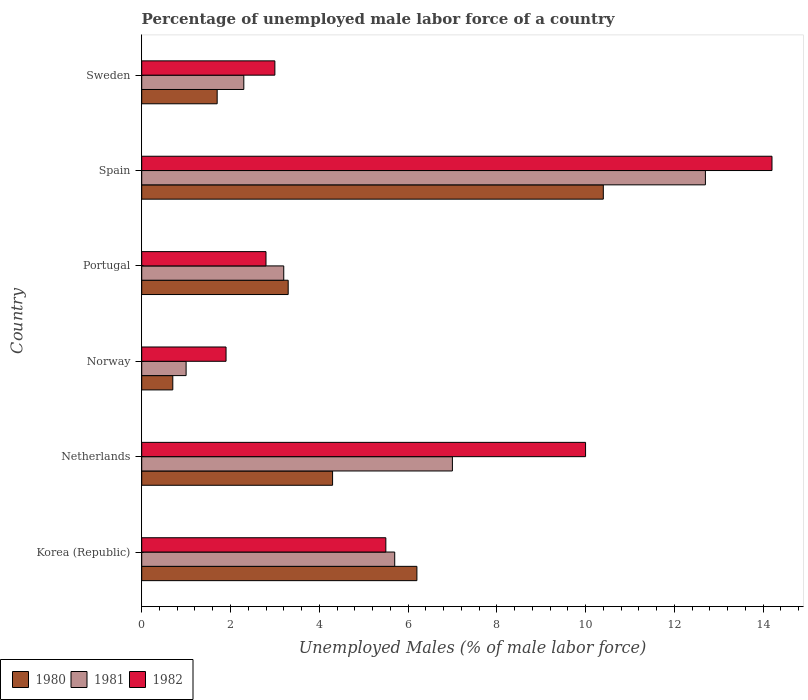Are the number of bars on each tick of the Y-axis equal?
Provide a short and direct response. Yes. How many bars are there on the 3rd tick from the top?
Your answer should be very brief. 3. What is the label of the 1st group of bars from the top?
Ensure brevity in your answer.  Sweden. In how many cases, is the number of bars for a given country not equal to the number of legend labels?
Keep it short and to the point. 0. What is the percentage of unemployed male labor force in 1982 in Norway?
Keep it short and to the point. 1.9. Across all countries, what is the maximum percentage of unemployed male labor force in 1981?
Make the answer very short. 12.7. Across all countries, what is the minimum percentage of unemployed male labor force in 1981?
Offer a terse response. 1. In which country was the percentage of unemployed male labor force in 1980 minimum?
Your answer should be compact. Norway. What is the total percentage of unemployed male labor force in 1980 in the graph?
Provide a succinct answer. 26.6. What is the difference between the percentage of unemployed male labor force in 1981 in Norway and that in Sweden?
Keep it short and to the point. -1.3. What is the difference between the percentage of unemployed male labor force in 1982 in Netherlands and the percentage of unemployed male labor force in 1981 in Portugal?
Your response must be concise. 6.8. What is the average percentage of unemployed male labor force in 1981 per country?
Provide a succinct answer. 5.32. What is the difference between the percentage of unemployed male labor force in 1980 and percentage of unemployed male labor force in 1981 in Norway?
Offer a very short reply. -0.3. In how many countries, is the percentage of unemployed male labor force in 1980 greater than 4.8 %?
Offer a terse response. 2. What is the ratio of the percentage of unemployed male labor force in 1980 in Norway to that in Sweden?
Your answer should be compact. 0.41. Is the percentage of unemployed male labor force in 1982 in Korea (Republic) less than that in Spain?
Make the answer very short. Yes. What is the difference between the highest and the second highest percentage of unemployed male labor force in 1981?
Provide a succinct answer. 5.7. What is the difference between the highest and the lowest percentage of unemployed male labor force in 1980?
Provide a short and direct response. 9.7. What does the 3rd bar from the top in Netherlands represents?
Provide a short and direct response. 1980. What does the 1st bar from the bottom in Portugal represents?
Ensure brevity in your answer.  1980. How many bars are there?
Your answer should be compact. 18. Are all the bars in the graph horizontal?
Your answer should be compact. Yes. How many countries are there in the graph?
Make the answer very short. 6. Does the graph contain any zero values?
Provide a succinct answer. No. Does the graph contain grids?
Your answer should be compact. No. How many legend labels are there?
Ensure brevity in your answer.  3. How are the legend labels stacked?
Offer a very short reply. Horizontal. What is the title of the graph?
Make the answer very short. Percentage of unemployed male labor force of a country. What is the label or title of the X-axis?
Give a very brief answer. Unemployed Males (% of male labor force). What is the label or title of the Y-axis?
Your response must be concise. Country. What is the Unemployed Males (% of male labor force) in 1980 in Korea (Republic)?
Your answer should be compact. 6.2. What is the Unemployed Males (% of male labor force) of 1981 in Korea (Republic)?
Provide a succinct answer. 5.7. What is the Unemployed Males (% of male labor force) in 1982 in Korea (Republic)?
Offer a terse response. 5.5. What is the Unemployed Males (% of male labor force) of 1980 in Netherlands?
Give a very brief answer. 4.3. What is the Unemployed Males (% of male labor force) of 1982 in Netherlands?
Provide a succinct answer. 10. What is the Unemployed Males (% of male labor force) in 1980 in Norway?
Offer a terse response. 0.7. What is the Unemployed Males (% of male labor force) of 1981 in Norway?
Make the answer very short. 1. What is the Unemployed Males (% of male labor force) of 1982 in Norway?
Ensure brevity in your answer.  1.9. What is the Unemployed Males (% of male labor force) in 1980 in Portugal?
Keep it short and to the point. 3.3. What is the Unemployed Males (% of male labor force) of 1981 in Portugal?
Ensure brevity in your answer.  3.2. What is the Unemployed Males (% of male labor force) in 1982 in Portugal?
Offer a terse response. 2.8. What is the Unemployed Males (% of male labor force) in 1980 in Spain?
Ensure brevity in your answer.  10.4. What is the Unemployed Males (% of male labor force) of 1981 in Spain?
Make the answer very short. 12.7. What is the Unemployed Males (% of male labor force) in 1982 in Spain?
Offer a terse response. 14.2. What is the Unemployed Males (% of male labor force) in 1980 in Sweden?
Keep it short and to the point. 1.7. What is the Unemployed Males (% of male labor force) of 1981 in Sweden?
Keep it short and to the point. 2.3. What is the Unemployed Males (% of male labor force) in 1982 in Sweden?
Your answer should be very brief. 3. Across all countries, what is the maximum Unemployed Males (% of male labor force) of 1980?
Offer a terse response. 10.4. Across all countries, what is the maximum Unemployed Males (% of male labor force) of 1981?
Keep it short and to the point. 12.7. Across all countries, what is the maximum Unemployed Males (% of male labor force) in 1982?
Keep it short and to the point. 14.2. Across all countries, what is the minimum Unemployed Males (% of male labor force) of 1980?
Offer a terse response. 0.7. Across all countries, what is the minimum Unemployed Males (% of male labor force) in 1982?
Your response must be concise. 1.9. What is the total Unemployed Males (% of male labor force) in 1980 in the graph?
Your answer should be very brief. 26.6. What is the total Unemployed Males (% of male labor force) in 1981 in the graph?
Your answer should be compact. 31.9. What is the total Unemployed Males (% of male labor force) in 1982 in the graph?
Make the answer very short. 37.4. What is the difference between the Unemployed Males (% of male labor force) in 1980 in Korea (Republic) and that in Netherlands?
Make the answer very short. 1.9. What is the difference between the Unemployed Males (% of male labor force) of 1982 in Korea (Republic) and that in Netherlands?
Ensure brevity in your answer.  -4.5. What is the difference between the Unemployed Males (% of male labor force) in 1980 in Korea (Republic) and that in Norway?
Provide a succinct answer. 5.5. What is the difference between the Unemployed Males (% of male labor force) of 1981 in Korea (Republic) and that in Norway?
Your answer should be very brief. 4.7. What is the difference between the Unemployed Males (% of male labor force) of 1980 in Korea (Republic) and that in Portugal?
Provide a succinct answer. 2.9. What is the difference between the Unemployed Males (% of male labor force) in 1982 in Korea (Republic) and that in Portugal?
Your answer should be very brief. 2.7. What is the difference between the Unemployed Males (% of male labor force) in 1980 in Korea (Republic) and that in Spain?
Give a very brief answer. -4.2. What is the difference between the Unemployed Males (% of male labor force) of 1981 in Korea (Republic) and that in Spain?
Your response must be concise. -7. What is the difference between the Unemployed Males (% of male labor force) in 1982 in Korea (Republic) and that in Spain?
Your answer should be compact. -8.7. What is the difference between the Unemployed Males (% of male labor force) in 1980 in Korea (Republic) and that in Sweden?
Your response must be concise. 4.5. What is the difference between the Unemployed Males (% of male labor force) in 1981 in Korea (Republic) and that in Sweden?
Offer a terse response. 3.4. What is the difference between the Unemployed Males (% of male labor force) in 1982 in Korea (Republic) and that in Sweden?
Offer a very short reply. 2.5. What is the difference between the Unemployed Males (% of male labor force) in 1980 in Netherlands and that in Norway?
Provide a short and direct response. 3.6. What is the difference between the Unemployed Males (% of male labor force) in 1980 in Netherlands and that in Portugal?
Your response must be concise. 1. What is the difference between the Unemployed Males (% of male labor force) of 1981 in Netherlands and that in Portugal?
Offer a terse response. 3.8. What is the difference between the Unemployed Males (% of male labor force) in 1982 in Netherlands and that in Portugal?
Provide a short and direct response. 7.2. What is the difference between the Unemployed Males (% of male labor force) in 1981 in Netherlands and that in Spain?
Offer a very short reply. -5.7. What is the difference between the Unemployed Males (% of male labor force) in 1982 in Netherlands and that in Spain?
Keep it short and to the point. -4.2. What is the difference between the Unemployed Males (% of male labor force) of 1980 in Netherlands and that in Sweden?
Keep it short and to the point. 2.6. What is the difference between the Unemployed Males (% of male labor force) in 1980 in Norway and that in Portugal?
Provide a short and direct response. -2.6. What is the difference between the Unemployed Males (% of male labor force) of 1980 in Norway and that in Spain?
Offer a very short reply. -9.7. What is the difference between the Unemployed Males (% of male labor force) of 1982 in Norway and that in Spain?
Provide a short and direct response. -12.3. What is the difference between the Unemployed Males (% of male labor force) of 1980 in Norway and that in Sweden?
Your answer should be compact. -1. What is the difference between the Unemployed Males (% of male labor force) of 1981 in Norway and that in Sweden?
Offer a very short reply. -1.3. What is the difference between the Unemployed Males (% of male labor force) in 1980 in Portugal and that in Spain?
Your response must be concise. -7.1. What is the difference between the Unemployed Males (% of male labor force) of 1981 in Portugal and that in Spain?
Your response must be concise. -9.5. What is the difference between the Unemployed Males (% of male labor force) in 1982 in Portugal and that in Spain?
Your answer should be compact. -11.4. What is the difference between the Unemployed Males (% of male labor force) in 1980 in Spain and that in Sweden?
Provide a short and direct response. 8.7. What is the difference between the Unemployed Males (% of male labor force) of 1980 in Korea (Republic) and the Unemployed Males (% of male labor force) of 1981 in Netherlands?
Your answer should be very brief. -0.8. What is the difference between the Unemployed Males (% of male labor force) of 1980 in Korea (Republic) and the Unemployed Males (% of male labor force) of 1982 in Netherlands?
Your answer should be compact. -3.8. What is the difference between the Unemployed Males (% of male labor force) of 1981 in Korea (Republic) and the Unemployed Males (% of male labor force) of 1982 in Netherlands?
Provide a short and direct response. -4.3. What is the difference between the Unemployed Males (% of male labor force) of 1980 in Korea (Republic) and the Unemployed Males (% of male labor force) of 1981 in Norway?
Provide a short and direct response. 5.2. What is the difference between the Unemployed Males (% of male labor force) in 1980 in Korea (Republic) and the Unemployed Males (% of male labor force) in 1982 in Spain?
Provide a short and direct response. -8. What is the difference between the Unemployed Males (% of male labor force) in 1980 in Korea (Republic) and the Unemployed Males (% of male labor force) in 1981 in Sweden?
Your answer should be very brief. 3.9. What is the difference between the Unemployed Males (% of male labor force) of 1980 in Korea (Republic) and the Unemployed Males (% of male labor force) of 1982 in Sweden?
Provide a short and direct response. 3.2. What is the difference between the Unemployed Males (% of male labor force) of 1981 in Netherlands and the Unemployed Males (% of male labor force) of 1982 in Portugal?
Your answer should be very brief. 4.2. What is the difference between the Unemployed Males (% of male labor force) in 1980 in Netherlands and the Unemployed Males (% of male labor force) in 1982 in Spain?
Your answer should be very brief. -9.9. What is the difference between the Unemployed Males (% of male labor force) in 1981 in Netherlands and the Unemployed Males (% of male labor force) in 1982 in Spain?
Provide a succinct answer. -7.2. What is the difference between the Unemployed Males (% of male labor force) of 1980 in Netherlands and the Unemployed Males (% of male labor force) of 1982 in Sweden?
Ensure brevity in your answer.  1.3. What is the difference between the Unemployed Males (% of male labor force) of 1981 in Netherlands and the Unemployed Males (% of male labor force) of 1982 in Sweden?
Keep it short and to the point. 4. What is the difference between the Unemployed Males (% of male labor force) of 1980 in Norway and the Unemployed Males (% of male labor force) of 1981 in Portugal?
Your answer should be compact. -2.5. What is the difference between the Unemployed Males (% of male labor force) in 1980 in Norway and the Unemployed Males (% of male labor force) in 1982 in Spain?
Give a very brief answer. -13.5. What is the difference between the Unemployed Males (% of male labor force) of 1981 in Norway and the Unemployed Males (% of male labor force) of 1982 in Spain?
Ensure brevity in your answer.  -13.2. What is the difference between the Unemployed Males (% of male labor force) in 1981 in Portugal and the Unemployed Males (% of male labor force) in 1982 in Sweden?
Provide a short and direct response. 0.2. What is the difference between the Unemployed Males (% of male labor force) in 1980 in Spain and the Unemployed Males (% of male labor force) in 1982 in Sweden?
Offer a terse response. 7.4. What is the average Unemployed Males (% of male labor force) in 1980 per country?
Provide a short and direct response. 4.43. What is the average Unemployed Males (% of male labor force) in 1981 per country?
Provide a short and direct response. 5.32. What is the average Unemployed Males (% of male labor force) in 1982 per country?
Your answer should be very brief. 6.23. What is the difference between the Unemployed Males (% of male labor force) in 1980 and Unemployed Males (% of male labor force) in 1982 in Korea (Republic)?
Keep it short and to the point. 0.7. What is the difference between the Unemployed Males (% of male labor force) of 1981 and Unemployed Males (% of male labor force) of 1982 in Netherlands?
Ensure brevity in your answer.  -3. What is the difference between the Unemployed Males (% of male labor force) in 1980 and Unemployed Males (% of male labor force) in 1982 in Norway?
Your response must be concise. -1.2. What is the difference between the Unemployed Males (% of male labor force) in 1980 and Unemployed Males (% of male labor force) in 1982 in Portugal?
Your answer should be very brief. 0.5. What is the difference between the Unemployed Males (% of male labor force) in 1980 and Unemployed Males (% of male labor force) in 1982 in Spain?
Offer a terse response. -3.8. What is the difference between the Unemployed Males (% of male labor force) in 1980 and Unemployed Males (% of male labor force) in 1981 in Sweden?
Give a very brief answer. -0.6. What is the difference between the Unemployed Males (% of male labor force) of 1980 and Unemployed Males (% of male labor force) of 1982 in Sweden?
Your answer should be very brief. -1.3. What is the difference between the Unemployed Males (% of male labor force) in 1981 and Unemployed Males (% of male labor force) in 1982 in Sweden?
Your answer should be compact. -0.7. What is the ratio of the Unemployed Males (% of male labor force) of 1980 in Korea (Republic) to that in Netherlands?
Your response must be concise. 1.44. What is the ratio of the Unemployed Males (% of male labor force) of 1981 in Korea (Republic) to that in Netherlands?
Ensure brevity in your answer.  0.81. What is the ratio of the Unemployed Males (% of male labor force) of 1982 in Korea (Republic) to that in Netherlands?
Provide a short and direct response. 0.55. What is the ratio of the Unemployed Males (% of male labor force) of 1980 in Korea (Republic) to that in Norway?
Offer a terse response. 8.86. What is the ratio of the Unemployed Males (% of male labor force) of 1982 in Korea (Republic) to that in Norway?
Keep it short and to the point. 2.89. What is the ratio of the Unemployed Males (% of male labor force) in 1980 in Korea (Republic) to that in Portugal?
Your answer should be very brief. 1.88. What is the ratio of the Unemployed Males (% of male labor force) of 1981 in Korea (Republic) to that in Portugal?
Provide a short and direct response. 1.78. What is the ratio of the Unemployed Males (% of male labor force) in 1982 in Korea (Republic) to that in Portugal?
Provide a short and direct response. 1.96. What is the ratio of the Unemployed Males (% of male labor force) of 1980 in Korea (Republic) to that in Spain?
Keep it short and to the point. 0.6. What is the ratio of the Unemployed Males (% of male labor force) of 1981 in Korea (Republic) to that in Spain?
Provide a succinct answer. 0.45. What is the ratio of the Unemployed Males (% of male labor force) of 1982 in Korea (Republic) to that in Spain?
Keep it short and to the point. 0.39. What is the ratio of the Unemployed Males (% of male labor force) of 1980 in Korea (Republic) to that in Sweden?
Offer a terse response. 3.65. What is the ratio of the Unemployed Males (% of male labor force) of 1981 in Korea (Republic) to that in Sweden?
Give a very brief answer. 2.48. What is the ratio of the Unemployed Males (% of male labor force) in 1982 in Korea (Republic) to that in Sweden?
Offer a very short reply. 1.83. What is the ratio of the Unemployed Males (% of male labor force) of 1980 in Netherlands to that in Norway?
Provide a short and direct response. 6.14. What is the ratio of the Unemployed Males (% of male labor force) of 1982 in Netherlands to that in Norway?
Ensure brevity in your answer.  5.26. What is the ratio of the Unemployed Males (% of male labor force) of 1980 in Netherlands to that in Portugal?
Offer a very short reply. 1.3. What is the ratio of the Unemployed Males (% of male labor force) of 1981 in Netherlands to that in Portugal?
Your answer should be compact. 2.19. What is the ratio of the Unemployed Males (% of male labor force) in 1982 in Netherlands to that in Portugal?
Offer a very short reply. 3.57. What is the ratio of the Unemployed Males (% of male labor force) in 1980 in Netherlands to that in Spain?
Give a very brief answer. 0.41. What is the ratio of the Unemployed Males (% of male labor force) in 1981 in Netherlands to that in Spain?
Provide a short and direct response. 0.55. What is the ratio of the Unemployed Males (% of male labor force) in 1982 in Netherlands to that in Spain?
Make the answer very short. 0.7. What is the ratio of the Unemployed Males (% of male labor force) of 1980 in Netherlands to that in Sweden?
Provide a succinct answer. 2.53. What is the ratio of the Unemployed Males (% of male labor force) in 1981 in Netherlands to that in Sweden?
Give a very brief answer. 3.04. What is the ratio of the Unemployed Males (% of male labor force) in 1980 in Norway to that in Portugal?
Ensure brevity in your answer.  0.21. What is the ratio of the Unemployed Males (% of male labor force) of 1981 in Norway to that in Portugal?
Provide a short and direct response. 0.31. What is the ratio of the Unemployed Males (% of male labor force) of 1982 in Norway to that in Portugal?
Your answer should be very brief. 0.68. What is the ratio of the Unemployed Males (% of male labor force) in 1980 in Norway to that in Spain?
Your answer should be compact. 0.07. What is the ratio of the Unemployed Males (% of male labor force) in 1981 in Norway to that in Spain?
Ensure brevity in your answer.  0.08. What is the ratio of the Unemployed Males (% of male labor force) in 1982 in Norway to that in Spain?
Your answer should be compact. 0.13. What is the ratio of the Unemployed Males (% of male labor force) in 1980 in Norway to that in Sweden?
Give a very brief answer. 0.41. What is the ratio of the Unemployed Males (% of male labor force) of 1981 in Norway to that in Sweden?
Offer a terse response. 0.43. What is the ratio of the Unemployed Males (% of male labor force) in 1982 in Norway to that in Sweden?
Provide a short and direct response. 0.63. What is the ratio of the Unemployed Males (% of male labor force) in 1980 in Portugal to that in Spain?
Offer a terse response. 0.32. What is the ratio of the Unemployed Males (% of male labor force) in 1981 in Portugal to that in Spain?
Offer a terse response. 0.25. What is the ratio of the Unemployed Males (% of male labor force) in 1982 in Portugal to that in Spain?
Ensure brevity in your answer.  0.2. What is the ratio of the Unemployed Males (% of male labor force) of 1980 in Portugal to that in Sweden?
Offer a terse response. 1.94. What is the ratio of the Unemployed Males (% of male labor force) of 1981 in Portugal to that in Sweden?
Offer a terse response. 1.39. What is the ratio of the Unemployed Males (% of male labor force) in 1982 in Portugal to that in Sweden?
Keep it short and to the point. 0.93. What is the ratio of the Unemployed Males (% of male labor force) of 1980 in Spain to that in Sweden?
Ensure brevity in your answer.  6.12. What is the ratio of the Unemployed Males (% of male labor force) in 1981 in Spain to that in Sweden?
Make the answer very short. 5.52. What is the ratio of the Unemployed Males (% of male labor force) in 1982 in Spain to that in Sweden?
Ensure brevity in your answer.  4.73. What is the difference between the highest and the second highest Unemployed Males (% of male labor force) of 1982?
Your answer should be very brief. 4.2. What is the difference between the highest and the lowest Unemployed Males (% of male labor force) of 1980?
Ensure brevity in your answer.  9.7. What is the difference between the highest and the lowest Unemployed Males (% of male labor force) of 1981?
Your response must be concise. 11.7. 